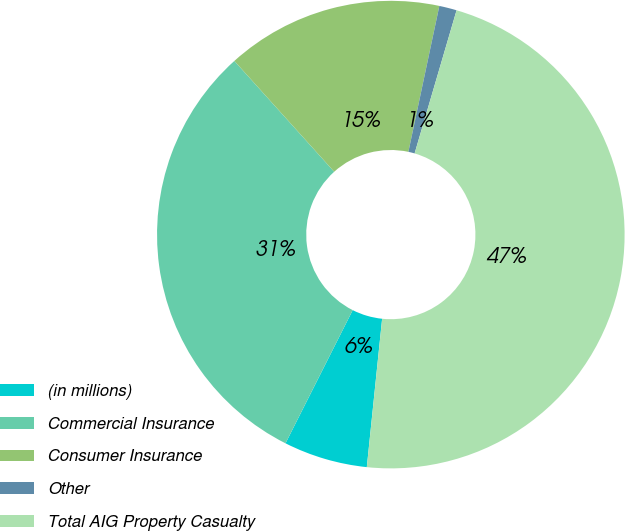Convert chart. <chart><loc_0><loc_0><loc_500><loc_500><pie_chart><fcel>(in millions)<fcel>Commercial Insurance<fcel>Consumer Insurance<fcel>Other<fcel>Total AIG Property Casualty<nl><fcel>5.8%<fcel>30.89%<fcel>15.0%<fcel>1.21%<fcel>47.1%<nl></chart> 